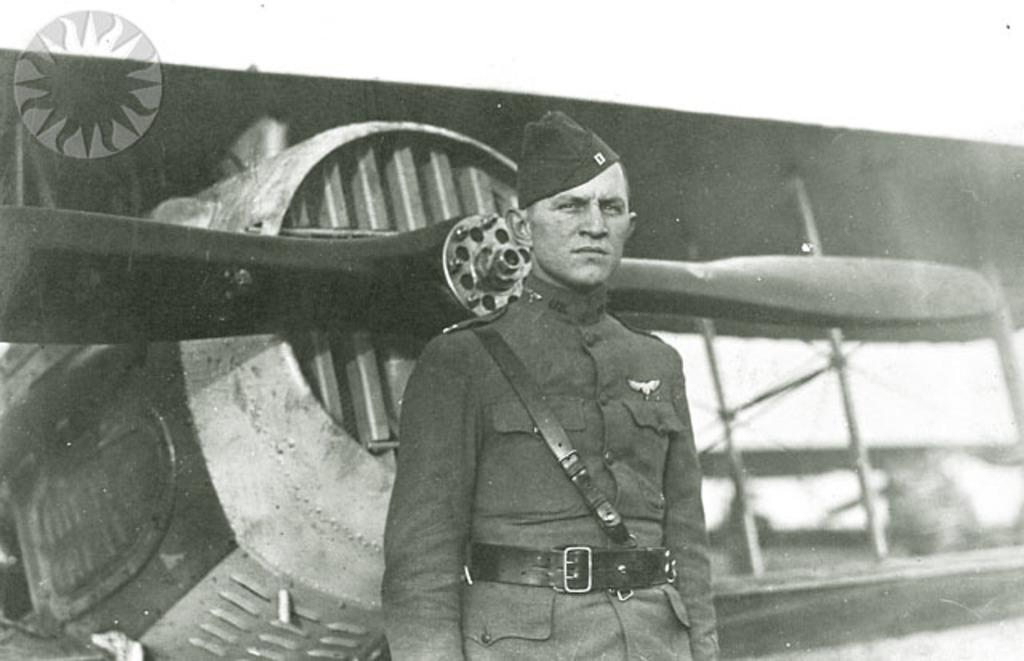What is the color scheme of the image? The image is black and white. Can you describe the main subject in the image? There is a person standing in the image. What can be seen in the background of the image? There is an airplane and the sky visible in the background. Is there any text or symbol present in the image? Yes, there is a logo in the image. What type of orange is the person holding in the image? There is no orange present in the image; it is a black and white image. What direction is the person facing in the image? The provided facts do not specify the direction the person is facing, so it cannot be determined from the image. 